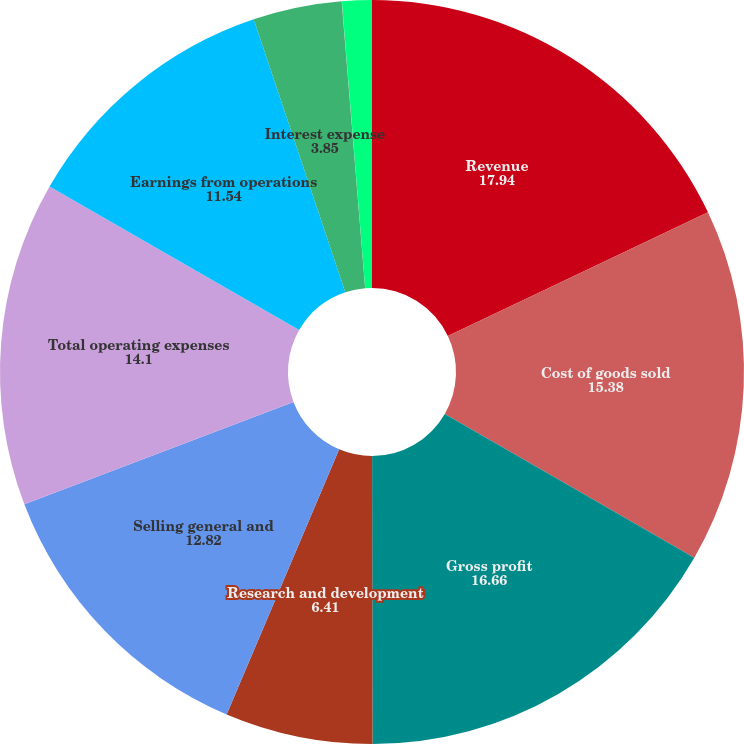<chart> <loc_0><loc_0><loc_500><loc_500><pie_chart><fcel>Revenue<fcel>Cost of goods sold<fcel>Gross profit<fcel>Research and development<fcel>Selling general and<fcel>Total operating expenses<fcel>Earnings from operations<fcel>Interest expense<fcel>Interest income<fcel>Other income net<nl><fcel>17.94%<fcel>15.38%<fcel>16.66%<fcel>6.41%<fcel>12.82%<fcel>14.1%<fcel>11.54%<fcel>3.85%<fcel>0.01%<fcel>1.29%<nl></chart> 